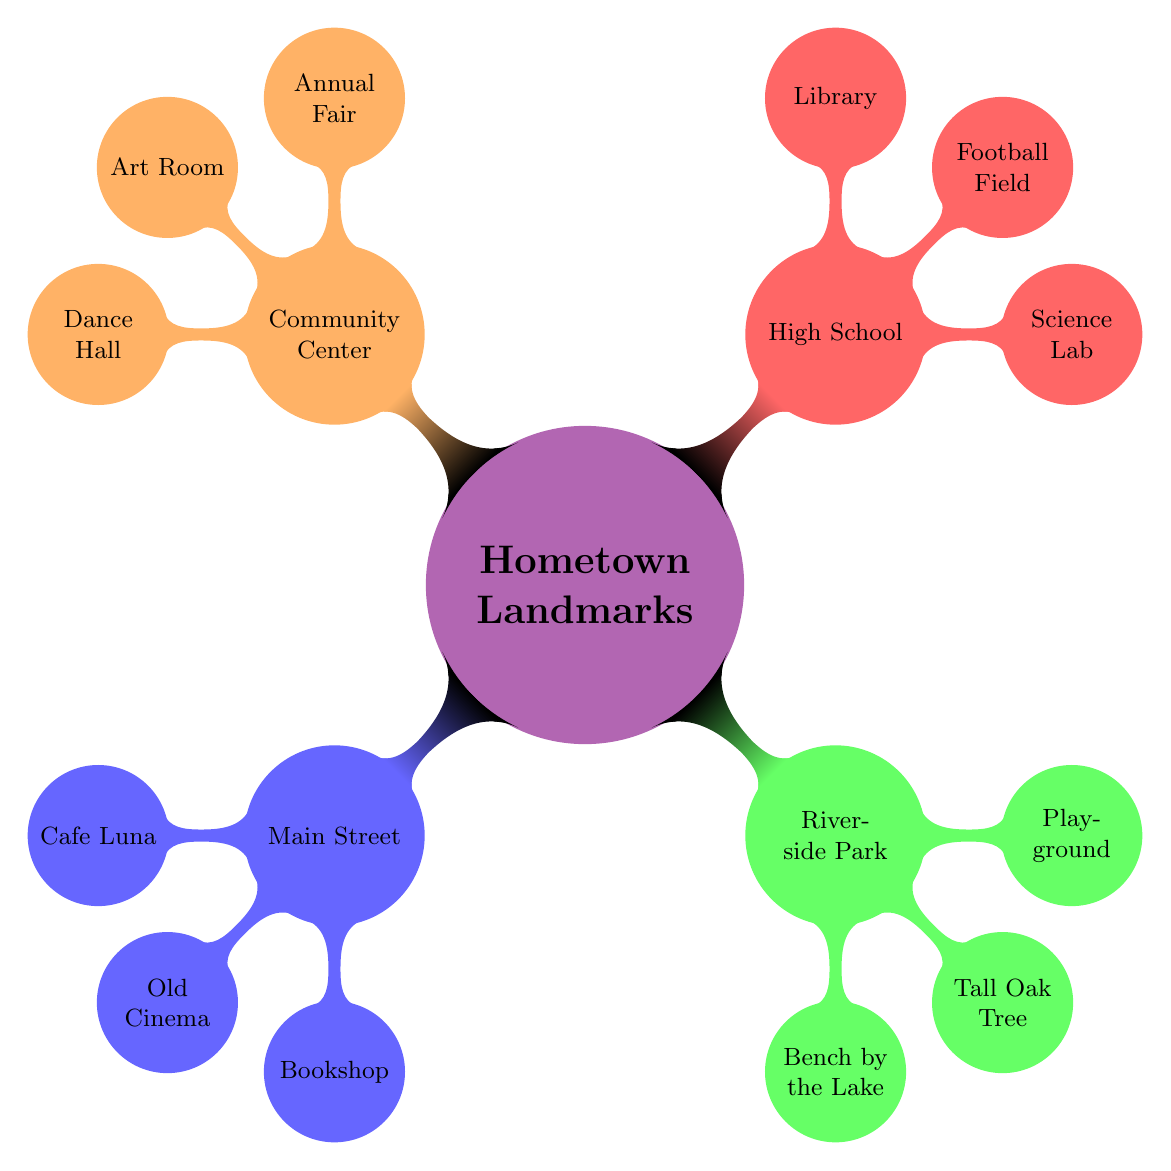What are three landmarks listed under Main Street? The diagram shows three specific landmarks under the Main Street node: Cafe Luna, Old Cinema, and Bookshop.
Answer: Cafe Luna, Old Cinema, Bookshop How many nodes are there under Riverside Park? There are three nodes listed under Riverside Park: Bench by the Lake, Tall Oak Tree, and Playground, making a total of three nodes.
Answer: 3 What was the significant event that took place in the Art Room? In the Community Center’s Art Room, murals were painted for town events, indicating it was a location for significant community involvement.
Answer: Painted murals for the town events Which landmark includes a bench? The Bench by the Lake is the specific node that mentions a bench in the Riverside Park section of the mind map.
Answer: Bench by the Lake Where did you conduct the famous volcano experiment? The famous baking soda volcano experiment was conducted in the Science Lab, which is a node under the High School.
Answer: Science Lab What is the relationship between the Playground and the first meeting? The diagram indicates that the Playground is where you met for the first time, indicating a personal connection to this landmark.
Answer: Where we met for the first time How many landmarks are shown in the Community Center? There are three landmarks listed in the Community Center: Annual Fair, Art Room, and Dance Hall, making a total of three.
Answer: 3 